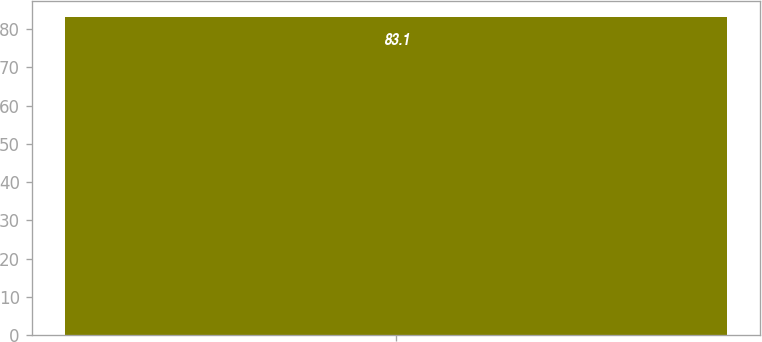Convert chart to OTSL. <chart><loc_0><loc_0><loc_500><loc_500><bar_chart><ecel><nl><fcel>83.1<nl></chart> 